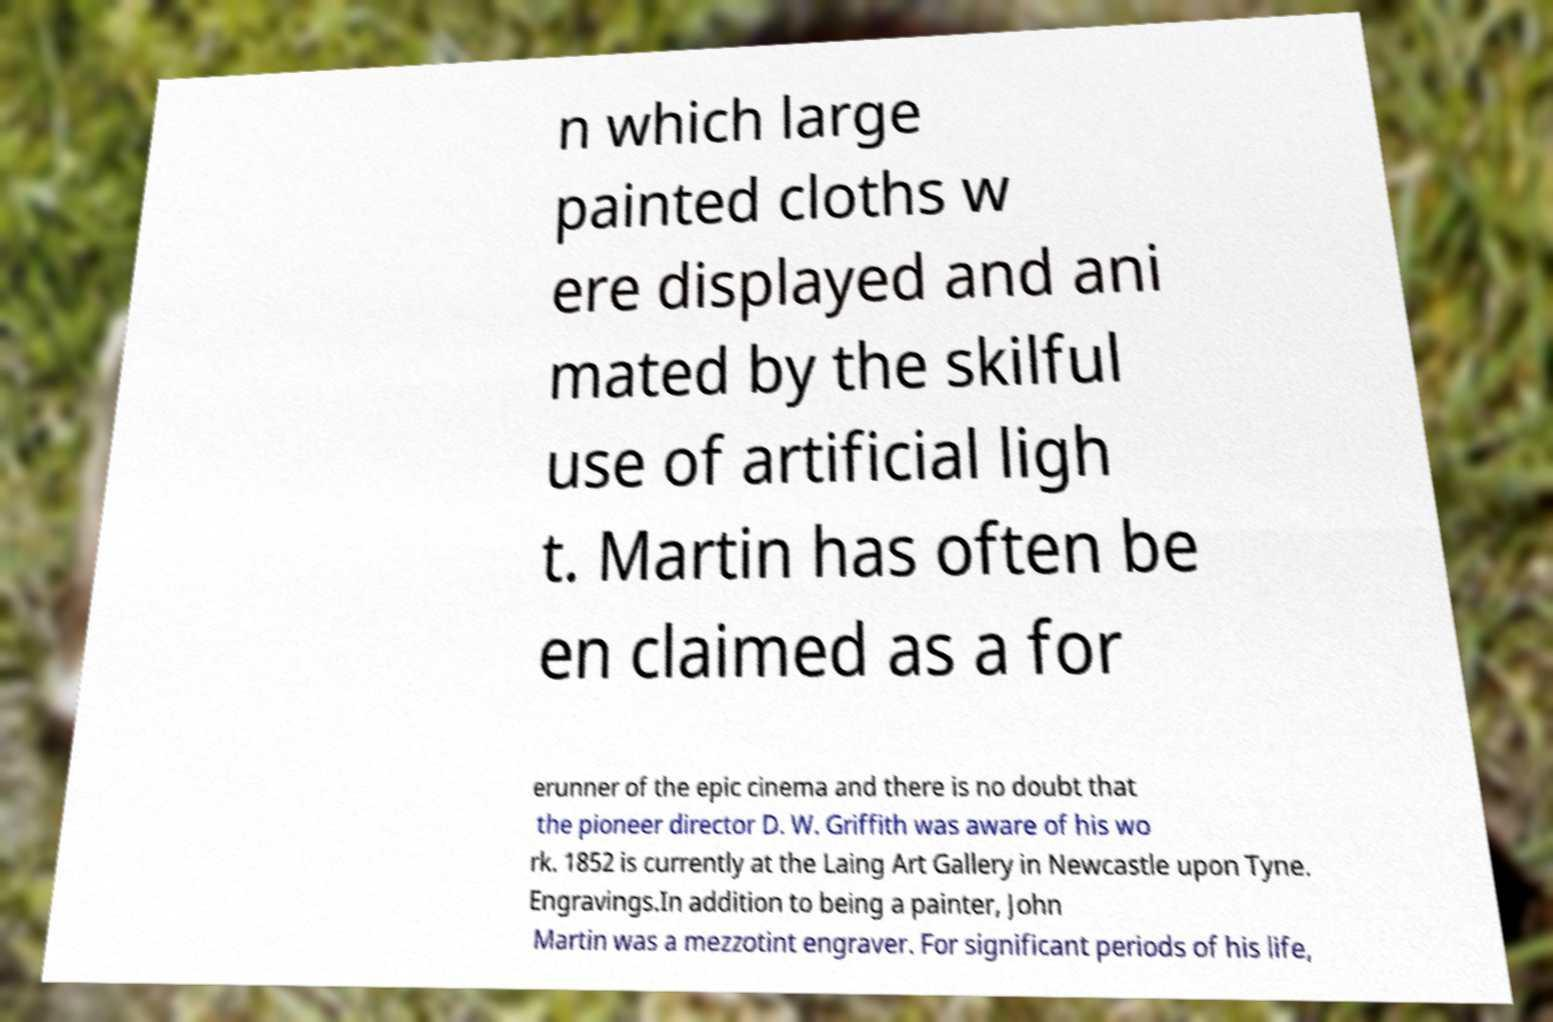Can you read and provide the text displayed in the image?This photo seems to have some interesting text. Can you extract and type it out for me? n which large painted cloths w ere displayed and ani mated by the skilful use of artificial ligh t. Martin has often be en claimed as a for erunner of the epic cinema and there is no doubt that the pioneer director D. W. Griffith was aware of his wo rk. 1852 is currently at the Laing Art Gallery in Newcastle upon Tyne. Engravings.In addition to being a painter, John Martin was a mezzotint engraver. For significant periods of his life, 